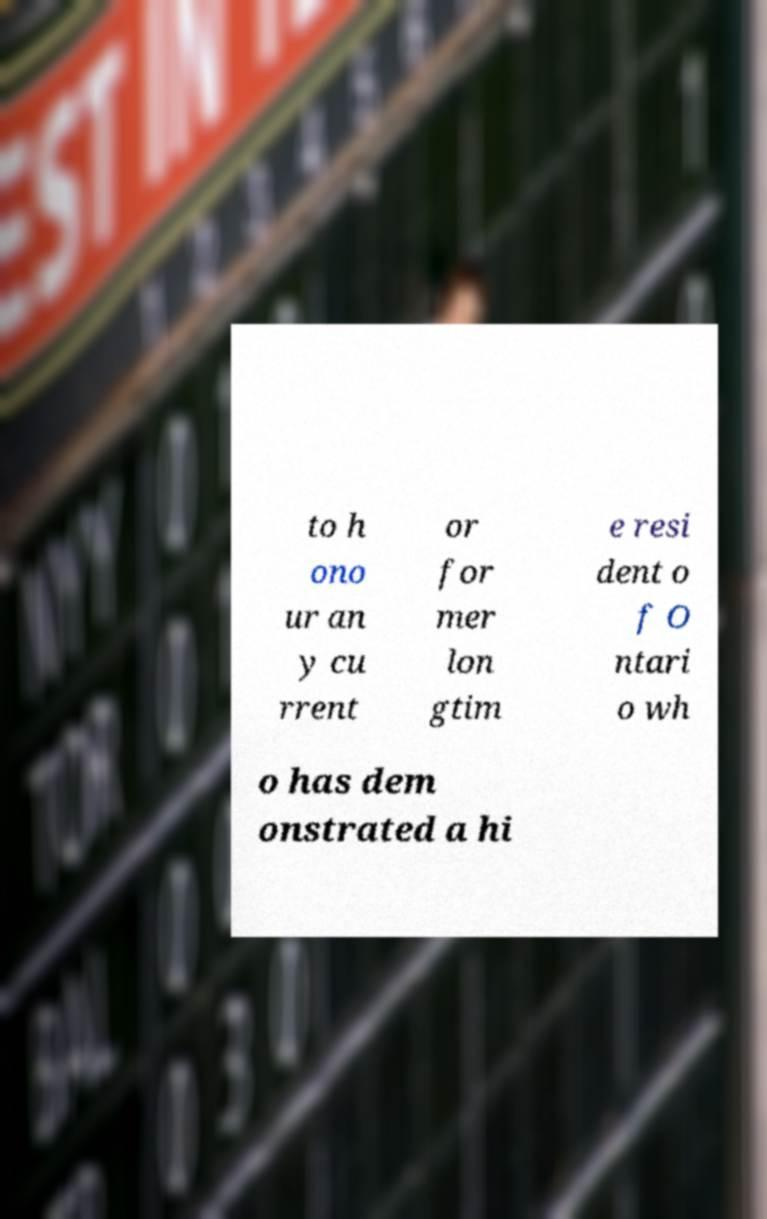Can you accurately transcribe the text from the provided image for me? to h ono ur an y cu rrent or for mer lon gtim e resi dent o f O ntari o wh o has dem onstrated a hi 